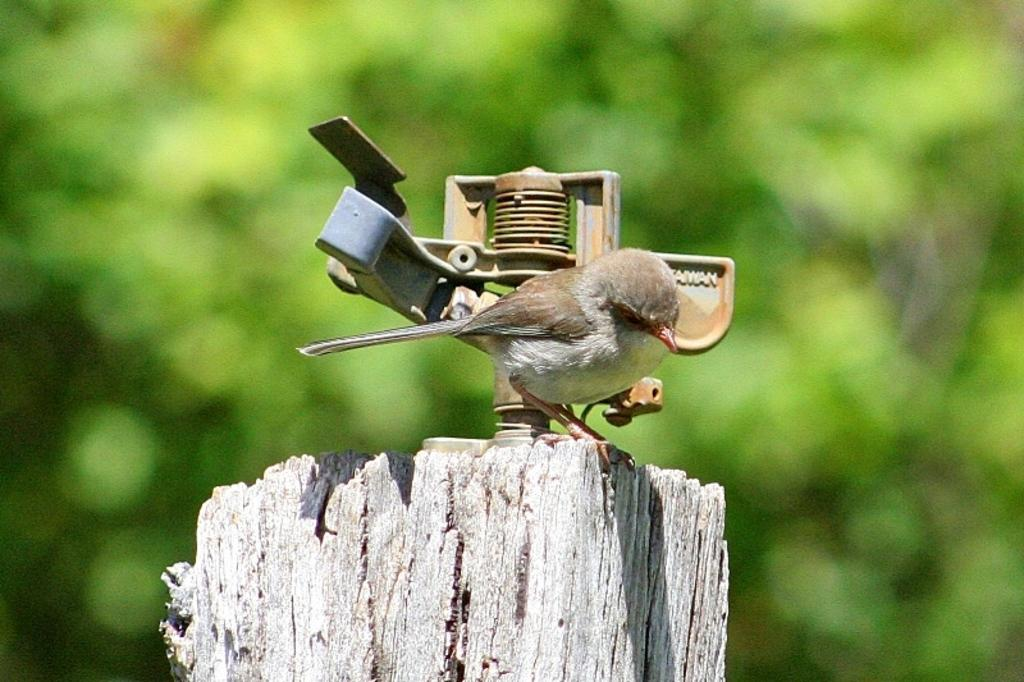What type of animal is standing in the image? There is a bird standing in the image. What material is at the bottom of the image? There is wood at the bottom of the image. What can be seen in the background of the image? There is a tree in the background of the image. How would you describe the appearance of the background in the image? The background of the image appears blurry. What type of rice is being processed in the image? There is no rice or process of any kind present in the image. 